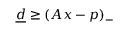<formula> <loc_0><loc_0><loc_500><loc_500>\underline { d } \geq ( A x - p ) _ { - }</formula> 